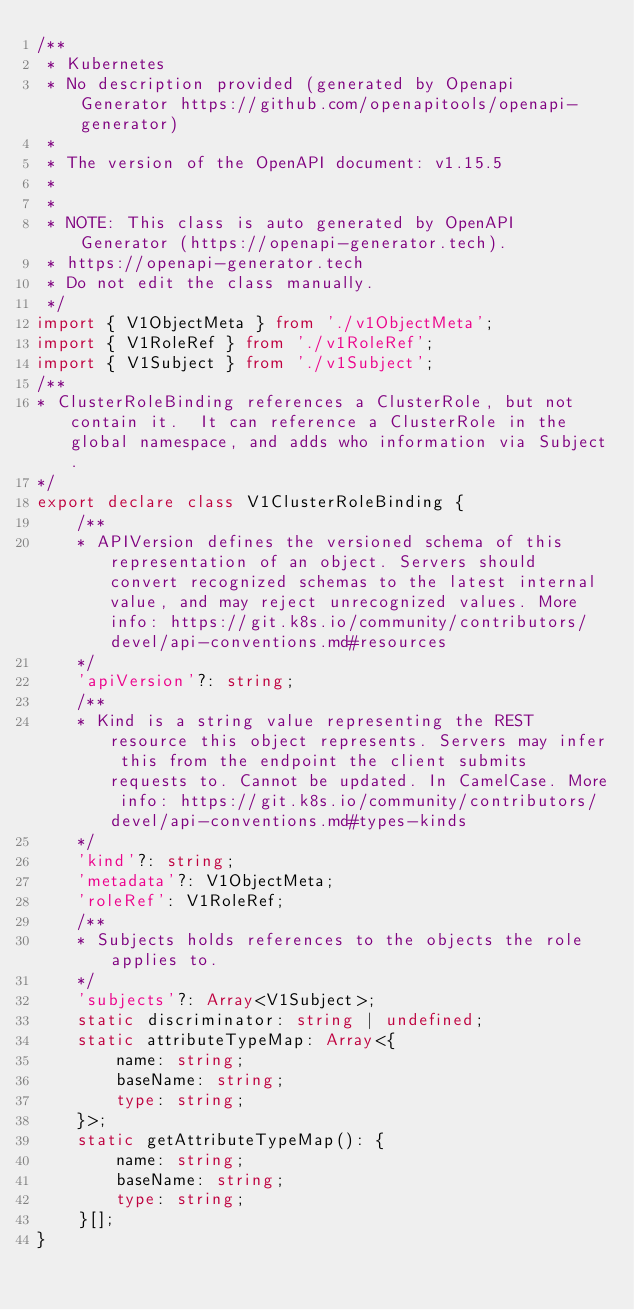Convert code to text. <code><loc_0><loc_0><loc_500><loc_500><_TypeScript_>/**
 * Kubernetes
 * No description provided (generated by Openapi Generator https://github.com/openapitools/openapi-generator)
 *
 * The version of the OpenAPI document: v1.15.5
 *
 *
 * NOTE: This class is auto generated by OpenAPI Generator (https://openapi-generator.tech).
 * https://openapi-generator.tech
 * Do not edit the class manually.
 */
import { V1ObjectMeta } from './v1ObjectMeta';
import { V1RoleRef } from './v1RoleRef';
import { V1Subject } from './v1Subject';
/**
* ClusterRoleBinding references a ClusterRole, but not contain it.  It can reference a ClusterRole in the global namespace, and adds who information via Subject.
*/
export declare class V1ClusterRoleBinding {
    /**
    * APIVersion defines the versioned schema of this representation of an object. Servers should convert recognized schemas to the latest internal value, and may reject unrecognized values. More info: https://git.k8s.io/community/contributors/devel/api-conventions.md#resources
    */
    'apiVersion'?: string;
    /**
    * Kind is a string value representing the REST resource this object represents. Servers may infer this from the endpoint the client submits requests to. Cannot be updated. In CamelCase. More info: https://git.k8s.io/community/contributors/devel/api-conventions.md#types-kinds
    */
    'kind'?: string;
    'metadata'?: V1ObjectMeta;
    'roleRef': V1RoleRef;
    /**
    * Subjects holds references to the objects the role applies to.
    */
    'subjects'?: Array<V1Subject>;
    static discriminator: string | undefined;
    static attributeTypeMap: Array<{
        name: string;
        baseName: string;
        type: string;
    }>;
    static getAttributeTypeMap(): {
        name: string;
        baseName: string;
        type: string;
    }[];
}
</code> 